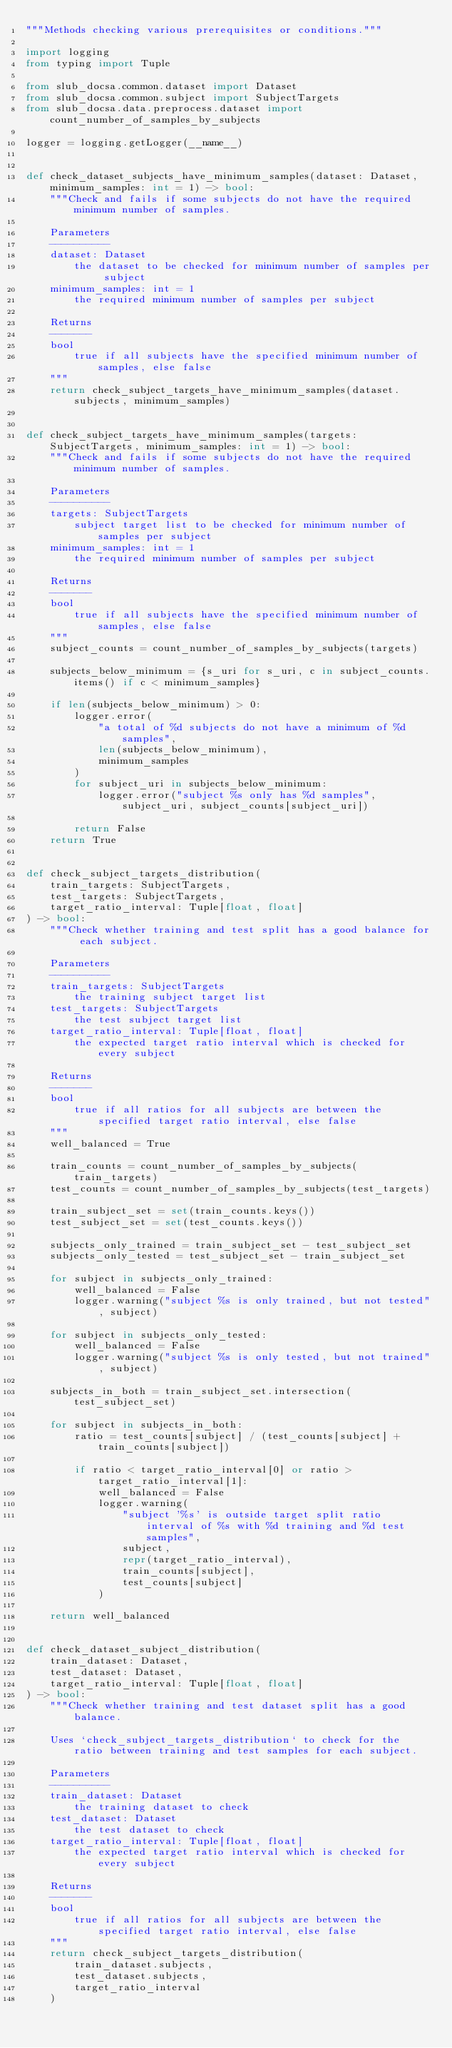<code> <loc_0><loc_0><loc_500><loc_500><_Python_>"""Methods checking various prerequisites or conditions."""

import logging
from typing import Tuple

from slub_docsa.common.dataset import Dataset
from slub_docsa.common.subject import SubjectTargets
from slub_docsa.data.preprocess.dataset import count_number_of_samples_by_subjects

logger = logging.getLogger(__name__)


def check_dataset_subjects_have_minimum_samples(dataset: Dataset, minimum_samples: int = 1) -> bool:
    """Check and fails if some subjects do not have the required minimum number of samples.

    Parameters
    ----------
    dataset: Dataset
        the dataset to be checked for minimum number of samples per subject
    minimum_samples: int = 1
        the required minimum number of samples per subject

    Returns
    -------
    bool
        true if all subjects have the specified minimum number of samples, else false
    """
    return check_subject_targets_have_minimum_samples(dataset.subjects, minimum_samples)


def check_subject_targets_have_minimum_samples(targets: SubjectTargets, minimum_samples: int = 1) -> bool:
    """Check and fails if some subjects do not have the required minimum number of samples.

    Parameters
    ----------
    targets: SubjectTargets
        subject target list to be checked for minimum number of samples per subject
    minimum_samples: int = 1
        the required minimum number of samples per subject

    Returns
    -------
    bool
        true if all subjects have the specified minimum number of samples, else false
    """
    subject_counts = count_number_of_samples_by_subjects(targets)

    subjects_below_minimum = {s_uri for s_uri, c in subject_counts.items() if c < minimum_samples}

    if len(subjects_below_minimum) > 0:
        logger.error(
            "a total of %d subjects do not have a minimum of %d samples",
            len(subjects_below_minimum),
            minimum_samples
        )
        for subject_uri in subjects_below_minimum:
            logger.error("subject %s only has %d samples", subject_uri, subject_counts[subject_uri])

        return False
    return True


def check_subject_targets_distribution(
    train_targets: SubjectTargets,
    test_targets: SubjectTargets,
    target_ratio_interval: Tuple[float, float]
) -> bool:
    """Check whether training and test split has a good balance for each subject.

    Parameters
    ----------
    train_targets: SubjectTargets
        the training subject target list
    test_targets: SubjectTargets
        the test subject target list
    target_ratio_interval: Tuple[float, float]
        the expected target ratio interval which is checked for every subject

    Returns
    -------
    bool
        true if all ratios for all subjects are between the specified target ratio interval, else false
    """
    well_balanced = True

    train_counts = count_number_of_samples_by_subjects(train_targets)
    test_counts = count_number_of_samples_by_subjects(test_targets)

    train_subject_set = set(train_counts.keys())
    test_subject_set = set(test_counts.keys())

    subjects_only_trained = train_subject_set - test_subject_set
    subjects_only_tested = test_subject_set - train_subject_set

    for subject in subjects_only_trained:
        well_balanced = False
        logger.warning("subject %s is only trained, but not tested", subject)

    for subject in subjects_only_tested:
        well_balanced = False
        logger.warning("subject %s is only tested, but not trained", subject)

    subjects_in_both = train_subject_set.intersection(test_subject_set)

    for subject in subjects_in_both:
        ratio = test_counts[subject] / (test_counts[subject] + train_counts[subject])

        if ratio < target_ratio_interval[0] or ratio > target_ratio_interval[1]:
            well_balanced = False
            logger.warning(
                "subject '%s' is outside target split ratio interval of %s with %d training and %d test samples",
                subject,
                repr(target_ratio_interval),
                train_counts[subject],
                test_counts[subject]
            )

    return well_balanced


def check_dataset_subject_distribution(
    train_dataset: Dataset,
    test_dataset: Dataset,
    target_ratio_interval: Tuple[float, float]
) -> bool:
    """Check whether training and test dataset split has a good balance.

    Uses `check_subject_targets_distribution` to check for the ratio between training and test samples for each subject.

    Parameters
    ----------
    train_dataset: Dataset
        the training dataset to check
    test_dataset: Dataset
        the test dataset to check
    target_ratio_interval: Tuple[float, float]
        the expected target ratio interval which is checked for every subject

    Returns
    -------
    bool
        true if all ratios for all subjects are between the specified target ratio interval, else false
    """
    return check_subject_targets_distribution(
        train_dataset.subjects,
        test_dataset.subjects,
        target_ratio_interval
    )
</code> 